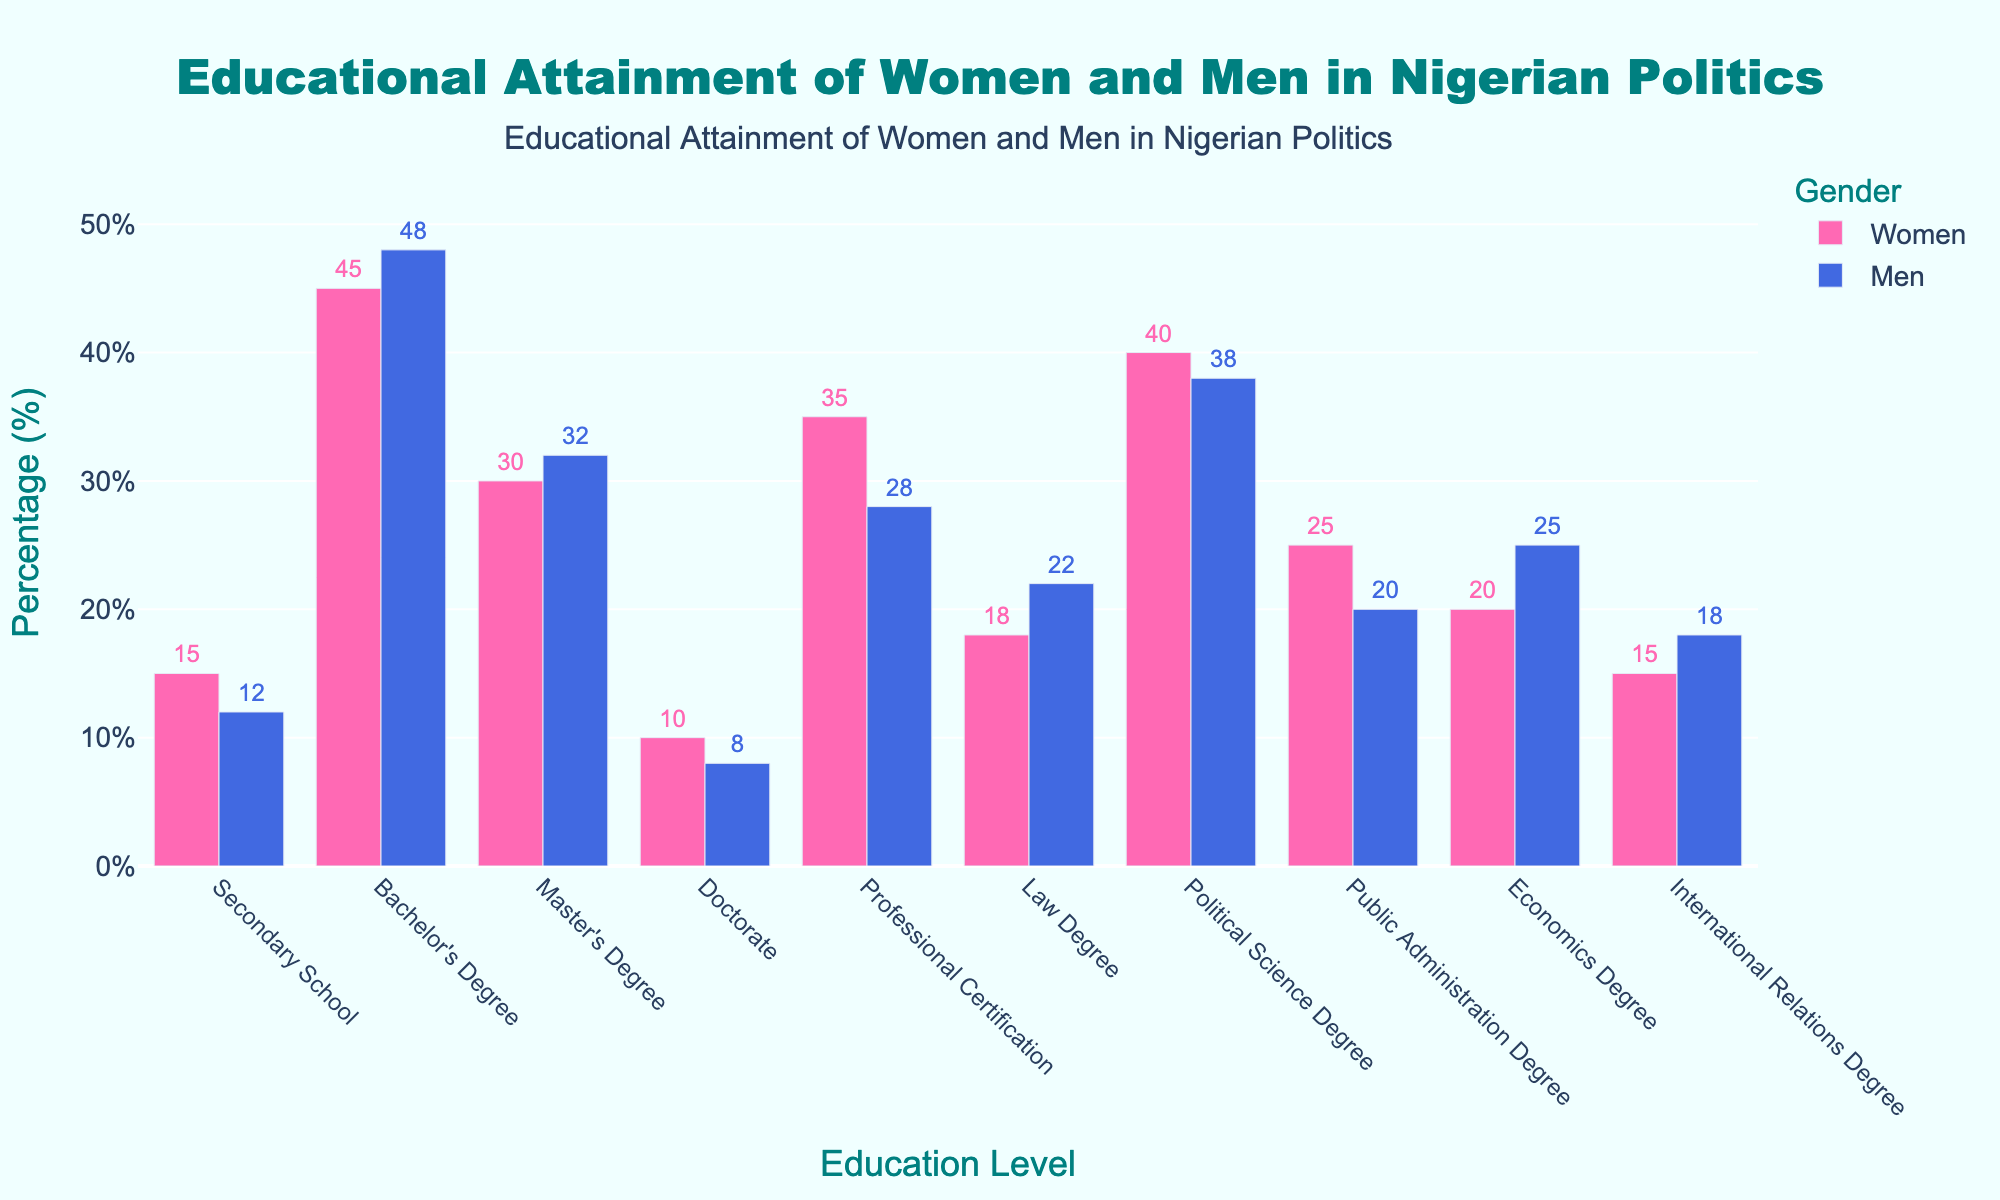Which gender has a higher percentage of political science degrees? The bar for women's political science degrees is slightly taller than the bar for men, indicating a higher percentage.
Answer: Women What is the percentage difference between women and men with secondary school education? The bar for women shows 15%, and the bar for men shows 12%. The difference is 15% - 12% = 3%.
Answer: 3% Which education level has the smallest gender difference? The bars for the bachelor's degree for women and men are very close, with women at 45% and men at 48%, resulting in a difference of 3%.
Answer: Bachelor's Degree Do more women or men have professional certifications? The bar for women with professional certifications is higher than that for men, with women at 35% and men at 28%.
Answer: Women What is the combined percentage of women with master's and doctorate degrees? The bar for women with master's degrees is 30%, and for doctorate degrees is 10%. The combined percentage is 30% + 10% = 40%.
Answer: 40% Which education level has a higher percentage for men than women? When comparing the heights of the bars, men have a higher percentage in law degrees (22% vs 18%) and economics degrees (25% vs 20%).
Answer: Law Degree and Economics Degree How much higher is the percentage of women with public administration degrees compared to men? The bar for women with public administration degrees is at 25%, while for men, it is at 20%. The difference is 25% - 20% = 5%.
Answer: 5% Which gender has a lower percentage for international relations degrees? The bar for women is at 15%, and the bar for men is at 18%, indicating that women have a lower percentage.
Answer: Women Do more women or men have bachelor's degrees? The bar for men is slightly higher than that for women, with men at 48% and women at 45%.
Answer: Men Are there more women or men with master's degrees by a wider margin compared to their doctorate degrees? For master's degrees, women are at 30% and men at 32% (2% difference). For doctorate degrees, women are at 10% and men at 8% (2% difference). The margin for both education levels is the same at 2%.
Answer: The same margin 